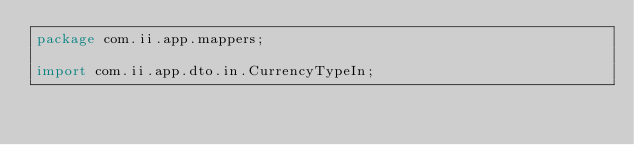Convert code to text. <code><loc_0><loc_0><loc_500><loc_500><_Java_>package com.ii.app.mappers;

import com.ii.app.dto.in.CurrencyTypeIn;</code> 